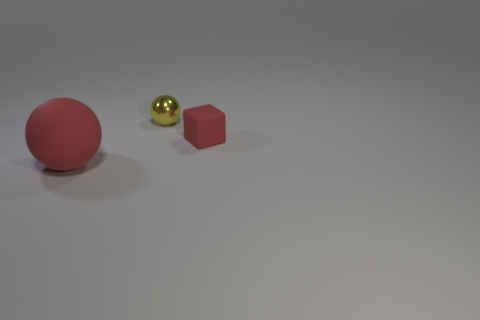Could you describe the lighting and shadows in the image? The lighting in the image comes from the upper left, casting soft shadows to the lower right of the objects. This indicates a diffused light source and contributes to the calm and serene atmosphere of the scene. 